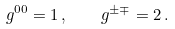<formula> <loc_0><loc_0><loc_500><loc_500>g ^ { 0 0 } = 1 \, , \quad g ^ { \pm \mp } = 2 \, .</formula> 